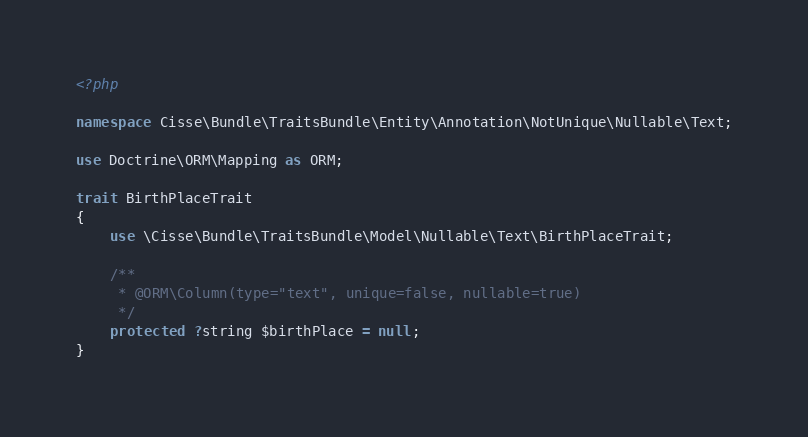Convert code to text. <code><loc_0><loc_0><loc_500><loc_500><_PHP_><?php

namespace Cisse\Bundle\TraitsBundle\Entity\Annotation\NotUnique\Nullable\Text;

use Doctrine\ORM\Mapping as ORM;

trait BirthPlaceTrait
{
    use \Cisse\Bundle\TraitsBundle\Model\Nullable\Text\BirthPlaceTrait;

    /**
     * @ORM\Column(type="text", unique=false, nullable=true)
     */
    protected ?string $birthPlace = null;
}
</code> 